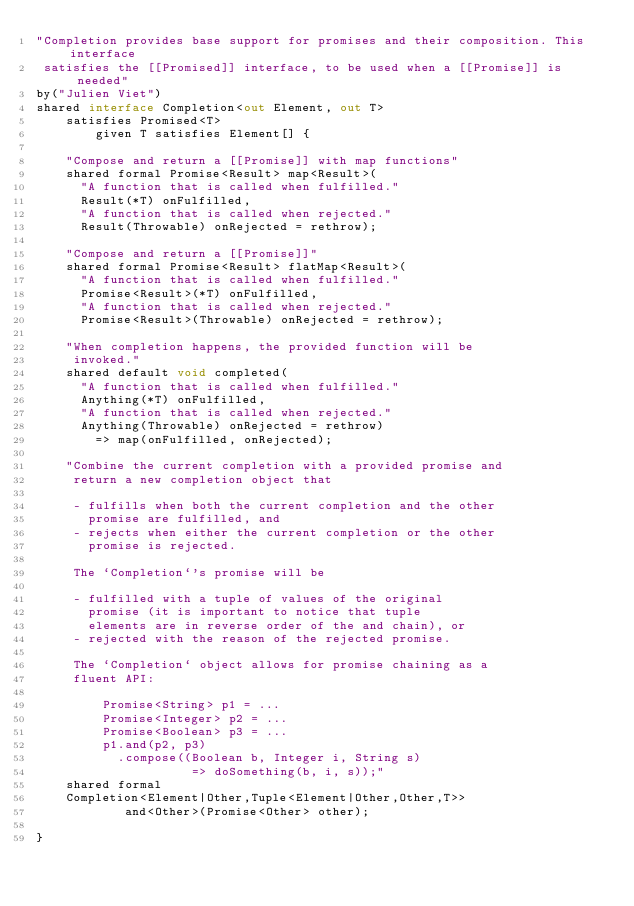Convert code to text. <code><loc_0><loc_0><loc_500><loc_500><_Ceylon_>"Completion provides base support for promises and their composition. This interface
 satisfies the [[Promised]] interface, to be used when a [[Promise]] is needed"
by("Julien Viet")
shared interface Completion<out Element, out T>
    satisfies Promised<T>
        given T satisfies Element[] {
    
    "Compose and return a [[Promise]] with map functions"
    shared formal Promise<Result> map<Result>(
      "A function that is called when fulfilled."
      Result(*T) onFulfilled,
      "A function that is called when rejected."
      Result(Throwable) onRejected = rethrow);
    
    "Compose and return a [[Promise]]"
    shared formal Promise<Result> flatMap<Result>(
      "A function that is called when fulfilled."
      Promise<Result>(*T) onFulfilled,
      "A function that is called when rejected."
      Promise<Result>(Throwable) onRejected = rethrow);
    
    "When completion happens, the provided function will be 
     invoked."
    shared default void completed(
      "A function that is called when fulfilled."
      Anything(*T) onFulfilled, 
      "A function that is called when rejected."
      Anything(Throwable) onRejected = rethrow)
        => map(onFulfilled, onRejected);

    "Combine the current completion with a provided promise and 
     return a new completion object that
     
     - fulfills when both the current completion and the other 
       promise are fulfilled, and
     - rejects when either the current completion or the other 
       promise is rejected.
     
     The `Completion`'s promise will be
     
     - fulfilled with a tuple of values of the original 
       promise (it is important to notice that tuple 
       elements are in reverse order of the and chain), or
     - rejected with the reason of the rejected promise.
    
     The `Completion` object allows for promise chaining as a 
     fluent API:
     
         Promise<String> p1 = ...
         Promise<Integer> p2 = ...
         Promise<Boolean> p3 = ...
         p1.and(p2, p3)
           .compose((Boolean b, Integer i, String s) 
                     => doSomething(b, i, s));"
    shared formal 
    Completion<Element|Other,Tuple<Element|Other,Other,T>> 
            and<Other>(Promise<Other> other);

}</code> 